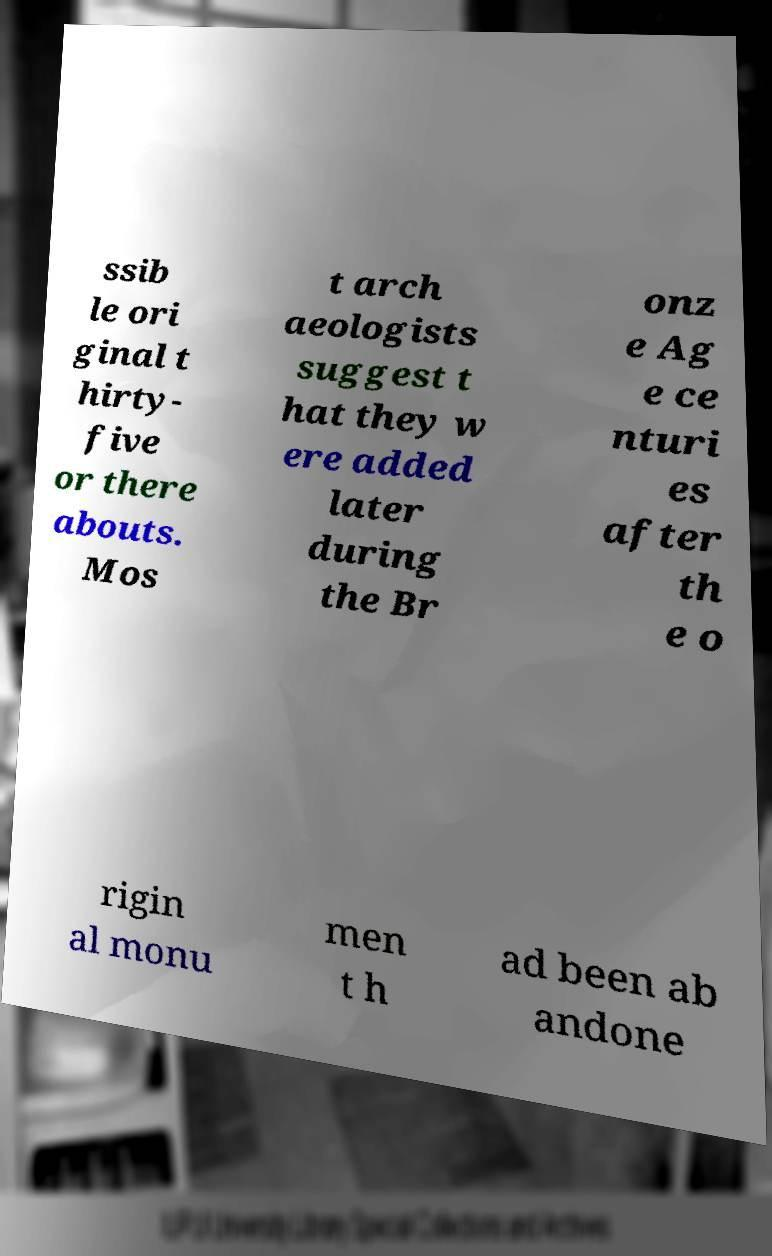Please identify and transcribe the text found in this image. ssib le ori ginal t hirty- five or there abouts. Mos t arch aeologists suggest t hat they w ere added later during the Br onz e Ag e ce nturi es after th e o rigin al monu men t h ad been ab andone 